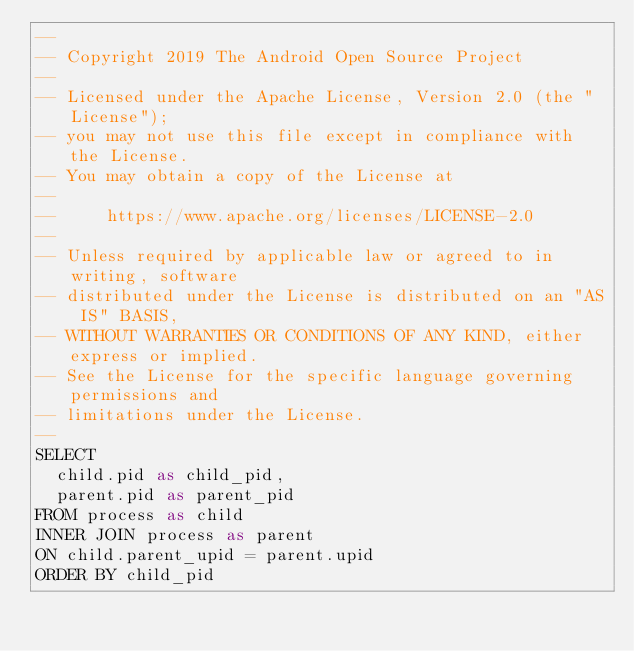Convert code to text. <code><loc_0><loc_0><loc_500><loc_500><_SQL_>--
-- Copyright 2019 The Android Open Source Project
--
-- Licensed under the Apache License, Version 2.0 (the "License");
-- you may not use this file except in compliance with the License.
-- You may obtain a copy of the License at
--
--     https://www.apache.org/licenses/LICENSE-2.0
--
-- Unless required by applicable law or agreed to in writing, software
-- distributed under the License is distributed on an "AS IS" BASIS,
-- WITHOUT WARRANTIES OR CONDITIONS OF ANY KIND, either express or implied.
-- See the License for the specific language governing permissions and
-- limitations under the License.
--
SELECT
  child.pid as child_pid,
  parent.pid as parent_pid
FROM process as child
INNER JOIN process as parent
ON child.parent_upid = parent.upid
ORDER BY child_pid
</code> 